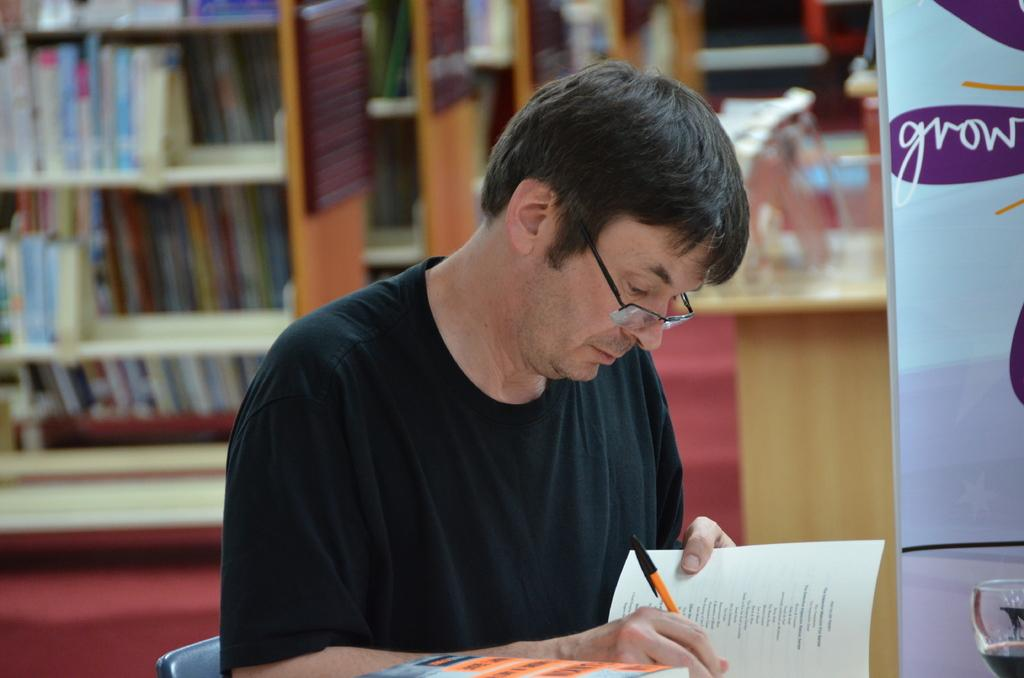What is the person in the image doing? The person is sitting on a chair in the image. What object is the person holding? The person is holding a pen. What item does the person have related to reading or learning? The person has a book. What can be seen in the background of the image? There are book racks and banners visible in the background. How would you describe the background of the image? The background is blurred. Can you tell me how many glasses are on the table in the image? There are no glasses visible in the image. What type of breath does the person have in the image? There is no indication of the person's breath in the image. 